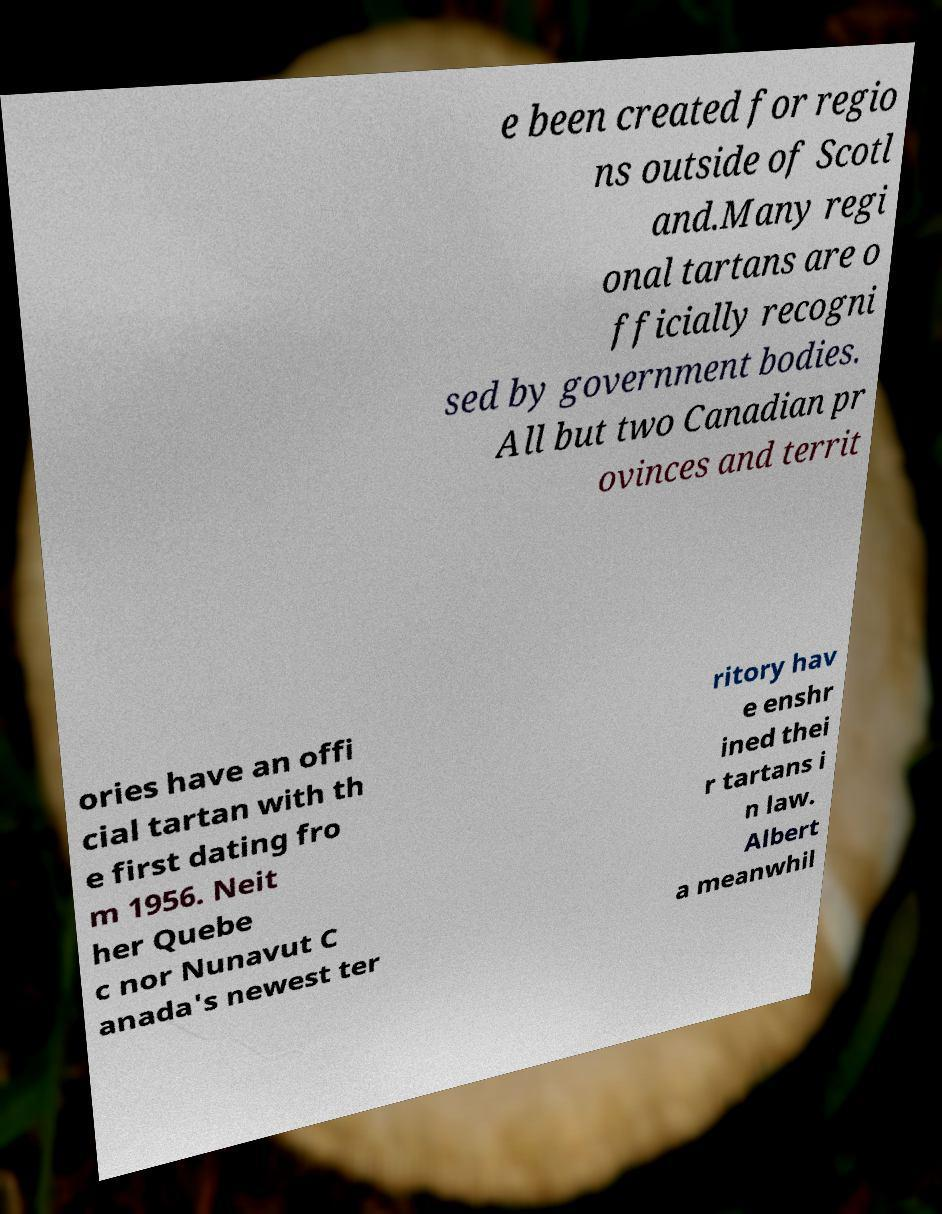For documentation purposes, I need the text within this image transcribed. Could you provide that? e been created for regio ns outside of Scotl and.Many regi onal tartans are o fficially recogni sed by government bodies. All but two Canadian pr ovinces and territ ories have an offi cial tartan with th e first dating fro m 1956. Neit her Quebe c nor Nunavut C anada's newest ter ritory hav e enshr ined thei r tartans i n law. Albert a meanwhil 